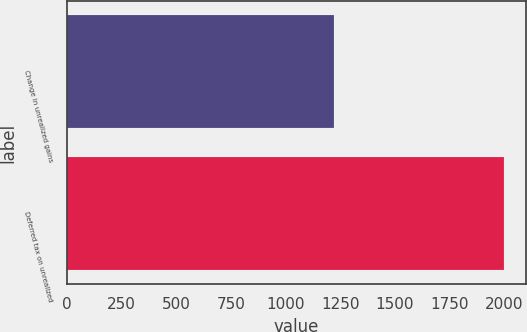Convert chart to OTSL. <chart><loc_0><loc_0><loc_500><loc_500><bar_chart><fcel>Change in unrealized gains<fcel>Deferred tax on unrealized<nl><fcel>1222<fcel>1999<nl></chart> 